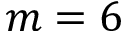Convert formula to latex. <formula><loc_0><loc_0><loc_500><loc_500>m = 6</formula> 